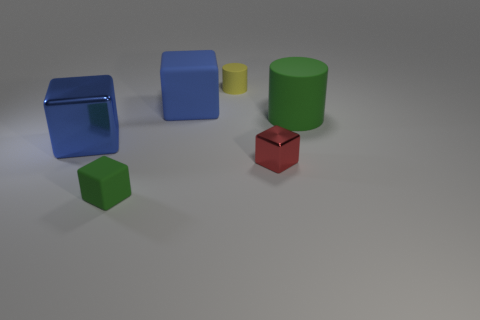Subtract all tiny red shiny cubes. How many cubes are left? 3 Subtract all green blocks. How many blocks are left? 3 Add 2 big blue matte cubes. How many objects exist? 8 Add 2 shiny objects. How many shiny objects are left? 4 Add 4 tiny gray metal cylinders. How many tiny gray metal cylinders exist? 4 Subtract 0 green balls. How many objects are left? 6 Subtract all blocks. How many objects are left? 2 Subtract 2 blocks. How many blocks are left? 2 Subtract all green cylinders. Subtract all blue balls. How many cylinders are left? 1 Subtract all purple cylinders. How many cyan cubes are left? 0 